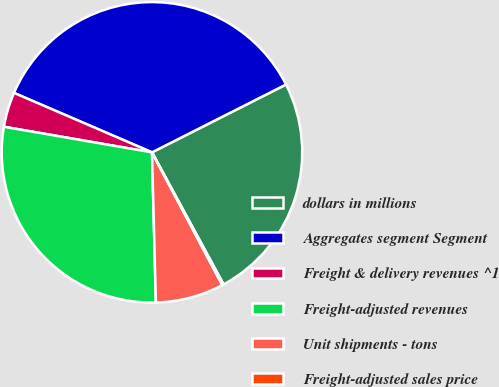<chart> <loc_0><loc_0><loc_500><loc_500><pie_chart><fcel>dollars in millions<fcel>Aggregates segment Segment<fcel>Freight & delivery revenues ^1<fcel>Freight-adjusted revenues<fcel>Unit shipments - tons<fcel>Freight-adjusted sales price<nl><fcel>24.55%<fcel>36.07%<fcel>3.75%<fcel>28.14%<fcel>7.34%<fcel>0.15%<nl></chart> 